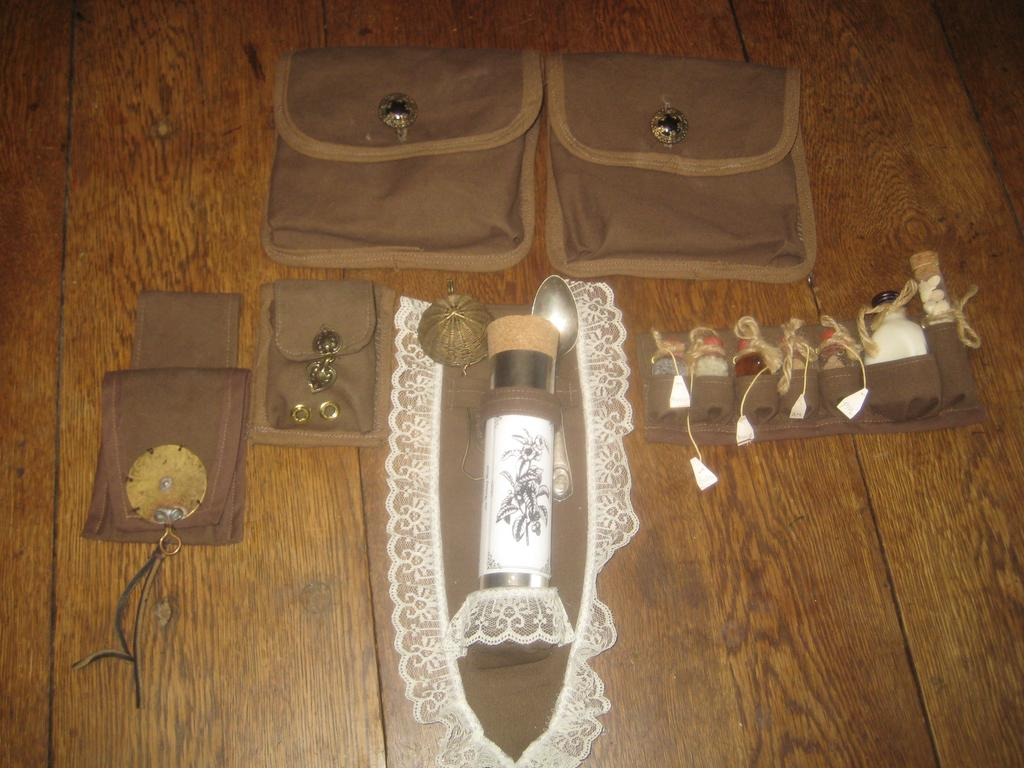What is the primary color of the pockets in the image? The primary color of the pockets in the image is brown. How are the brown color pockets arranged in the image? The brown color pockets are arranged on a wooden surface. Can you describe the texture of the surface on which the pockets are arranged? The surface is wooden, which suggests a smooth and solid texture. How many feet can be seen in the image? There are no feet visible in the image; it features brown color pockets arranged on a wooden surface. Is there a bird's nest present in the image? There is no bird's nest present in the image; it features brown color pockets arranged on a wooden surface. 